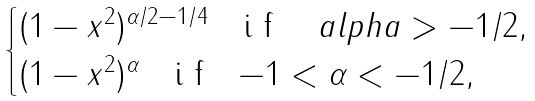<formula> <loc_0><loc_0><loc_500><loc_500>\begin{cases} ( 1 - x ^ { 2 } ) ^ { \alpha / 2 - 1 / 4 } \ \ $ i f $ \quad a l p h a > - 1 / 2 , \\ ( 1 - x ^ { 2 } ) ^ { \alpha } \ \ $ i f $ \ \ - 1 < \alpha < - 1 / 2 , \end{cases}</formula> 